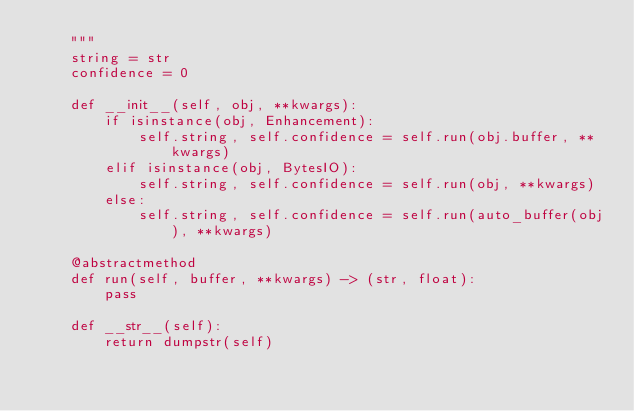Convert code to text. <code><loc_0><loc_0><loc_500><loc_500><_Python_>    """
    string = str
    confidence = 0

    def __init__(self, obj, **kwargs):
        if isinstance(obj, Enhancement):
            self.string, self.confidence = self.run(obj.buffer, **kwargs)
        elif isinstance(obj, BytesIO):
            self.string, self.confidence = self.run(obj, **kwargs)
        else:
            self.string, self.confidence = self.run(auto_buffer(obj), **kwargs)

    @abstractmethod
    def run(self, buffer, **kwargs) -> (str, float):
        pass

    def __str__(self):
        return dumpstr(self)</code> 